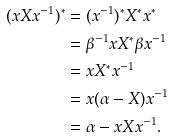Convert formula to latex. <formula><loc_0><loc_0><loc_500><loc_500>( x X x ^ { - 1 } ) ^ { \ast } & = ( x ^ { - 1 } ) ^ { \ast } X ^ { \ast } x ^ { \ast } \\ & = \beta ^ { - 1 } x X ^ { \ast } \beta x ^ { - 1 } \\ & = x X ^ { \ast } x ^ { - 1 } \\ & = x ( \alpha - X ) x ^ { - 1 } \\ & = \alpha - x X x ^ { - 1 } .</formula> 